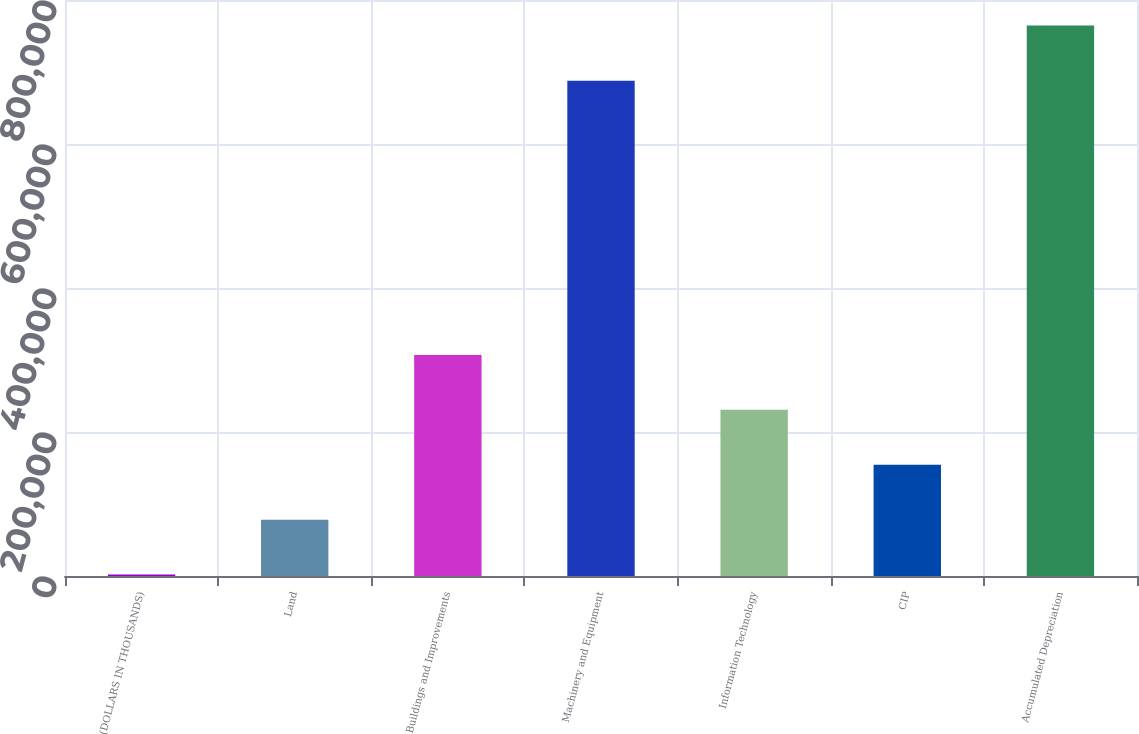Convert chart to OTSL. <chart><loc_0><loc_0><loc_500><loc_500><bar_chart><fcel>(DOLLARS IN THOUSANDS)<fcel>Land<fcel>Buildings and Improvements<fcel>Machinery and Equipment<fcel>Information Technology<fcel>CIP<fcel>Accumulated Depreciation<nl><fcel>2009<fcel>78267.3<fcel>307042<fcel>688007<fcel>230784<fcel>154526<fcel>764592<nl></chart> 